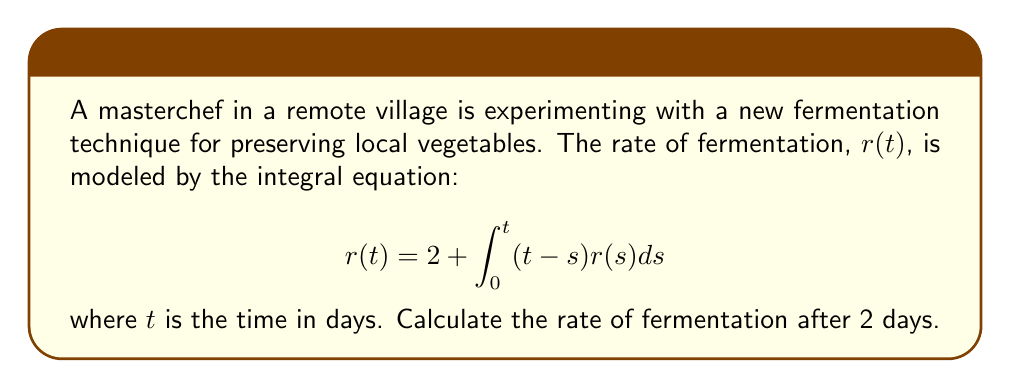Could you help me with this problem? To solve this integral equation, we'll use the Laplace transform method:

1) Take the Laplace transform of both sides:
   $$\mathcal{L}\{r(t)\} = \mathcal{L}\{2\} + \mathcal{L}\{\int_0^t (t-s)r(s)ds\}$$

2) Let $R(p)$ be the Laplace transform of $r(t)$. Using Laplace transform properties:
   $$R(p) = \frac{2}{p} + \frac{1}{p^2}R(p)$$

3) Solve for $R(p)$:
   $$R(p)(1 - \frac{1}{p^2}) = \frac{2}{p}$$
   $$R(p) = \frac{2p}{p^2 - 1}$$

4) Decompose into partial fractions:
   $$R(p) = \frac{1}{p-1} + \frac{1}{p+1}$$

5) Take the inverse Laplace transform:
   $$r(t) = e^t + e^{-t}$$

6) Evaluate at $t=2$:
   $$r(2) = e^2 + e^{-2}$$

7) Calculate the numerical value:
   $$r(2) \approx 7.3891$$
Answer: $7.3891$ 